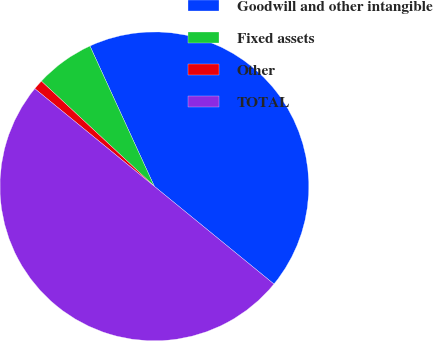<chart> <loc_0><loc_0><loc_500><loc_500><pie_chart><fcel>Goodwill and other intangible<fcel>Fixed assets<fcel>Other<fcel>TOTAL<nl><fcel>42.75%<fcel>6.22%<fcel>1.03%<fcel>50.0%<nl></chart> 